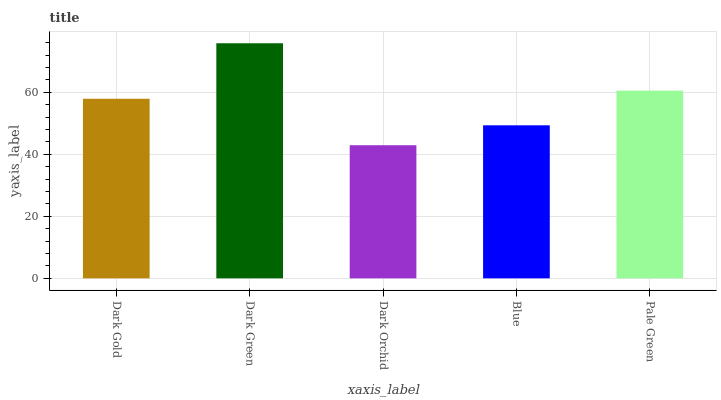Is Dark Green the minimum?
Answer yes or no. No. Is Dark Orchid the maximum?
Answer yes or no. No. Is Dark Green greater than Dark Orchid?
Answer yes or no. Yes. Is Dark Orchid less than Dark Green?
Answer yes or no. Yes. Is Dark Orchid greater than Dark Green?
Answer yes or no. No. Is Dark Green less than Dark Orchid?
Answer yes or no. No. Is Dark Gold the high median?
Answer yes or no. Yes. Is Dark Gold the low median?
Answer yes or no. Yes. Is Dark Green the high median?
Answer yes or no. No. Is Dark Green the low median?
Answer yes or no. No. 